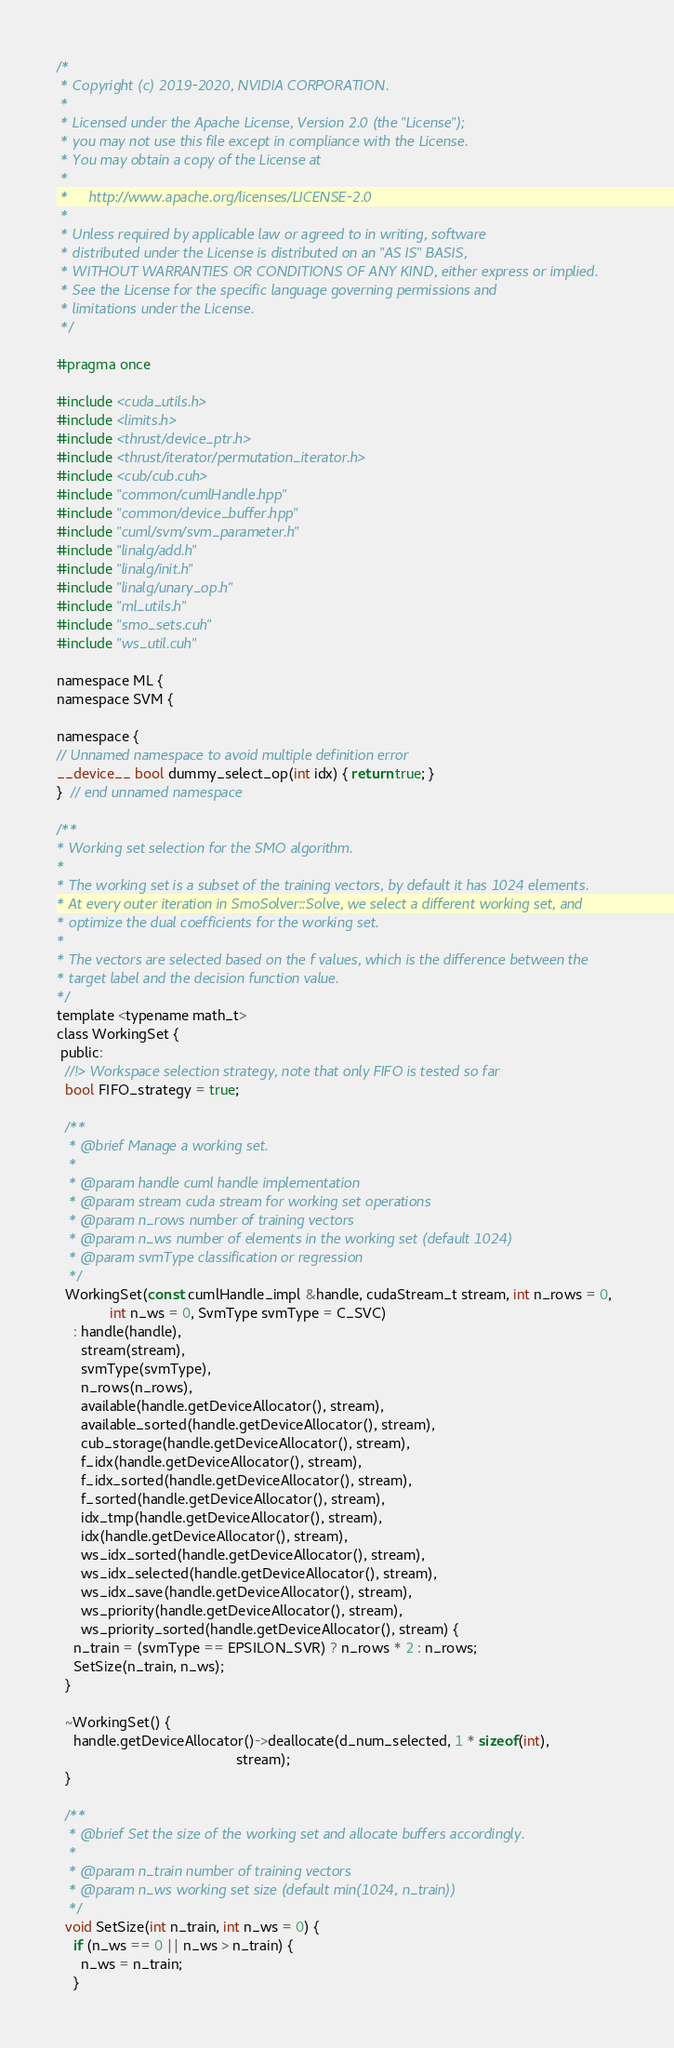<code> <loc_0><loc_0><loc_500><loc_500><_Cuda_>/*
 * Copyright (c) 2019-2020, NVIDIA CORPORATION.
 *
 * Licensed under the Apache License, Version 2.0 (the "License");
 * you may not use this file except in compliance with the License.
 * You may obtain a copy of the License at
 *
 *     http://www.apache.org/licenses/LICENSE-2.0
 *
 * Unless required by applicable law or agreed to in writing, software
 * distributed under the License is distributed on an "AS IS" BASIS,
 * WITHOUT WARRANTIES OR CONDITIONS OF ANY KIND, either express or implied.
 * See the License for the specific language governing permissions and
 * limitations under the License.
 */

#pragma once

#include <cuda_utils.h>
#include <limits.h>
#include <thrust/device_ptr.h>
#include <thrust/iterator/permutation_iterator.h>
#include <cub/cub.cuh>
#include "common/cumlHandle.hpp"
#include "common/device_buffer.hpp"
#include "cuml/svm/svm_parameter.h"
#include "linalg/add.h"
#include "linalg/init.h"
#include "linalg/unary_op.h"
#include "ml_utils.h"
#include "smo_sets.cuh"
#include "ws_util.cuh"

namespace ML {
namespace SVM {

namespace {
// Unnamed namespace to avoid multiple definition error
__device__ bool dummy_select_op(int idx) { return true; }
}  // end unnamed namespace

/**
* Working set selection for the SMO algorithm.
*
* The working set is a subset of the training vectors, by default it has 1024 elements.
* At every outer iteration in SmoSolver::Solve, we select a different working set, and
* optimize the dual coefficients for the working set.
*
* The vectors are selected based on the f values, which is the difference between the
* target label and the decision function value.
*/
template <typename math_t>
class WorkingSet {
 public:
  //!> Workspace selection strategy, note that only FIFO is tested so far
  bool FIFO_strategy = true;

  /**
   * @brief Manage a working set.
   *
   * @param handle cuml handle implementation
   * @param stream cuda stream for working set operations
   * @param n_rows number of training vectors
   * @param n_ws number of elements in the working set (default 1024)
   * @param svmType classification or regression
   */
  WorkingSet(const cumlHandle_impl &handle, cudaStream_t stream, int n_rows = 0,
             int n_ws = 0, SvmType svmType = C_SVC)
    : handle(handle),
      stream(stream),
      svmType(svmType),
      n_rows(n_rows),
      available(handle.getDeviceAllocator(), stream),
      available_sorted(handle.getDeviceAllocator(), stream),
      cub_storage(handle.getDeviceAllocator(), stream),
      f_idx(handle.getDeviceAllocator(), stream),
      f_idx_sorted(handle.getDeviceAllocator(), stream),
      f_sorted(handle.getDeviceAllocator(), stream),
      idx_tmp(handle.getDeviceAllocator(), stream),
      idx(handle.getDeviceAllocator(), stream),
      ws_idx_sorted(handle.getDeviceAllocator(), stream),
      ws_idx_selected(handle.getDeviceAllocator(), stream),
      ws_idx_save(handle.getDeviceAllocator(), stream),
      ws_priority(handle.getDeviceAllocator(), stream),
      ws_priority_sorted(handle.getDeviceAllocator(), stream) {
    n_train = (svmType == EPSILON_SVR) ? n_rows * 2 : n_rows;
    SetSize(n_train, n_ws);
  }

  ~WorkingSet() {
    handle.getDeviceAllocator()->deallocate(d_num_selected, 1 * sizeof(int),
                                            stream);
  }

  /**
   * @brief Set the size of the working set and allocate buffers accordingly.
   *
   * @param n_train number of training vectors
   * @param n_ws working set size (default min(1024, n_train))
   */
  void SetSize(int n_train, int n_ws = 0) {
    if (n_ws == 0 || n_ws > n_train) {
      n_ws = n_train;
    }</code> 